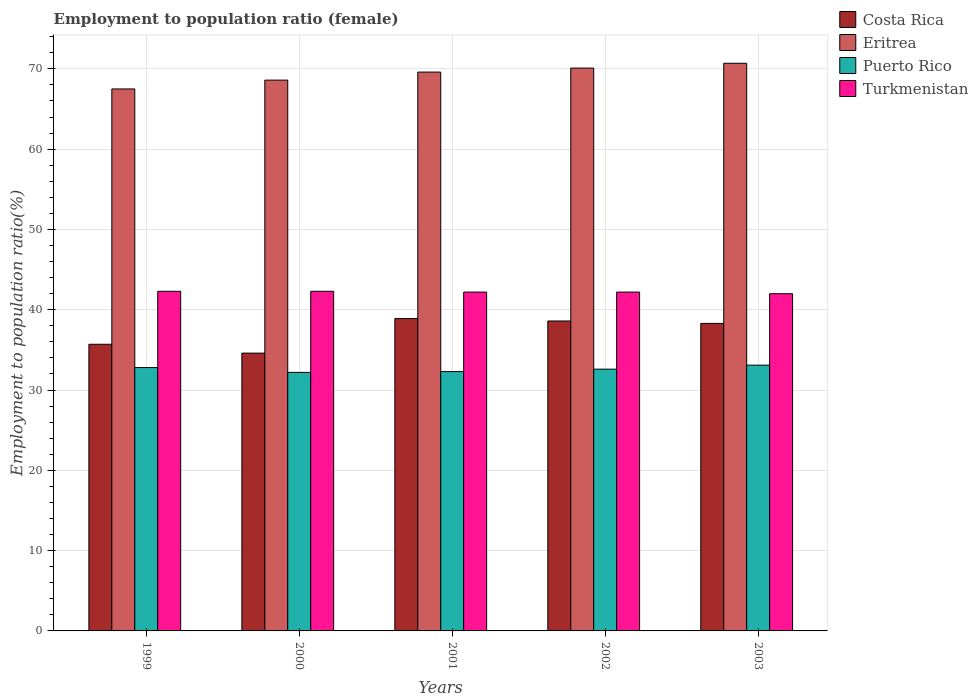How many groups of bars are there?
Make the answer very short. 5. Are the number of bars per tick equal to the number of legend labels?
Your response must be concise. Yes. Are the number of bars on each tick of the X-axis equal?
Offer a terse response. Yes. What is the employment to population ratio in Costa Rica in 1999?
Your answer should be very brief. 35.7. Across all years, what is the maximum employment to population ratio in Eritrea?
Your answer should be compact. 70.7. Across all years, what is the minimum employment to population ratio in Eritrea?
Provide a succinct answer. 67.5. In which year was the employment to population ratio in Turkmenistan maximum?
Offer a very short reply. 1999. In which year was the employment to population ratio in Turkmenistan minimum?
Make the answer very short. 2003. What is the total employment to population ratio in Puerto Rico in the graph?
Offer a terse response. 163. What is the difference between the employment to population ratio in Turkmenistan in 1999 and that in 2002?
Your answer should be compact. 0.1. What is the difference between the employment to population ratio in Eritrea in 2001 and the employment to population ratio in Costa Rica in 2002?
Make the answer very short. 31. What is the average employment to population ratio in Puerto Rico per year?
Keep it short and to the point. 32.6. In the year 2001, what is the difference between the employment to population ratio in Turkmenistan and employment to population ratio in Eritrea?
Ensure brevity in your answer.  -27.4. In how many years, is the employment to population ratio in Puerto Rico greater than 18 %?
Make the answer very short. 5. What is the ratio of the employment to population ratio in Turkmenistan in 1999 to that in 2003?
Make the answer very short. 1.01. What is the difference between the highest and the second highest employment to population ratio in Costa Rica?
Offer a very short reply. 0.3. What is the difference between the highest and the lowest employment to population ratio in Eritrea?
Your answer should be compact. 3.2. Is the sum of the employment to population ratio in Eritrea in 2001 and 2002 greater than the maximum employment to population ratio in Puerto Rico across all years?
Offer a terse response. Yes. What does the 4th bar from the left in 2000 represents?
Keep it short and to the point. Turkmenistan. Is it the case that in every year, the sum of the employment to population ratio in Costa Rica and employment to population ratio in Turkmenistan is greater than the employment to population ratio in Puerto Rico?
Keep it short and to the point. Yes. How many years are there in the graph?
Your answer should be compact. 5. Does the graph contain any zero values?
Ensure brevity in your answer.  No. Does the graph contain grids?
Provide a succinct answer. Yes. What is the title of the graph?
Offer a terse response. Employment to population ratio (female). What is the Employment to population ratio(%) of Costa Rica in 1999?
Ensure brevity in your answer.  35.7. What is the Employment to population ratio(%) of Eritrea in 1999?
Your answer should be compact. 67.5. What is the Employment to population ratio(%) of Puerto Rico in 1999?
Provide a succinct answer. 32.8. What is the Employment to population ratio(%) in Turkmenistan in 1999?
Your answer should be very brief. 42.3. What is the Employment to population ratio(%) of Costa Rica in 2000?
Offer a terse response. 34.6. What is the Employment to population ratio(%) of Eritrea in 2000?
Give a very brief answer. 68.6. What is the Employment to population ratio(%) of Puerto Rico in 2000?
Keep it short and to the point. 32.2. What is the Employment to population ratio(%) in Turkmenistan in 2000?
Offer a very short reply. 42.3. What is the Employment to population ratio(%) of Costa Rica in 2001?
Your response must be concise. 38.9. What is the Employment to population ratio(%) of Eritrea in 2001?
Provide a succinct answer. 69.6. What is the Employment to population ratio(%) of Puerto Rico in 2001?
Provide a succinct answer. 32.3. What is the Employment to population ratio(%) in Turkmenistan in 2001?
Make the answer very short. 42.2. What is the Employment to population ratio(%) of Costa Rica in 2002?
Make the answer very short. 38.6. What is the Employment to population ratio(%) of Eritrea in 2002?
Your response must be concise. 70.1. What is the Employment to population ratio(%) in Puerto Rico in 2002?
Your answer should be compact. 32.6. What is the Employment to population ratio(%) of Turkmenistan in 2002?
Keep it short and to the point. 42.2. What is the Employment to population ratio(%) of Costa Rica in 2003?
Your answer should be very brief. 38.3. What is the Employment to population ratio(%) of Eritrea in 2003?
Your response must be concise. 70.7. What is the Employment to population ratio(%) of Puerto Rico in 2003?
Offer a terse response. 33.1. Across all years, what is the maximum Employment to population ratio(%) of Costa Rica?
Keep it short and to the point. 38.9. Across all years, what is the maximum Employment to population ratio(%) of Eritrea?
Your answer should be compact. 70.7. Across all years, what is the maximum Employment to population ratio(%) in Puerto Rico?
Give a very brief answer. 33.1. Across all years, what is the maximum Employment to population ratio(%) in Turkmenistan?
Your response must be concise. 42.3. Across all years, what is the minimum Employment to population ratio(%) of Costa Rica?
Keep it short and to the point. 34.6. Across all years, what is the minimum Employment to population ratio(%) in Eritrea?
Offer a very short reply. 67.5. Across all years, what is the minimum Employment to population ratio(%) of Puerto Rico?
Provide a short and direct response. 32.2. What is the total Employment to population ratio(%) of Costa Rica in the graph?
Give a very brief answer. 186.1. What is the total Employment to population ratio(%) in Eritrea in the graph?
Offer a terse response. 346.5. What is the total Employment to population ratio(%) of Puerto Rico in the graph?
Your response must be concise. 163. What is the total Employment to population ratio(%) in Turkmenistan in the graph?
Your answer should be very brief. 211. What is the difference between the Employment to population ratio(%) of Costa Rica in 1999 and that in 2000?
Offer a terse response. 1.1. What is the difference between the Employment to population ratio(%) of Puerto Rico in 1999 and that in 2000?
Your answer should be very brief. 0.6. What is the difference between the Employment to population ratio(%) of Eritrea in 1999 and that in 2001?
Your response must be concise. -2.1. What is the difference between the Employment to population ratio(%) of Costa Rica in 1999 and that in 2002?
Ensure brevity in your answer.  -2.9. What is the difference between the Employment to population ratio(%) in Eritrea in 1999 and that in 2002?
Ensure brevity in your answer.  -2.6. What is the difference between the Employment to population ratio(%) in Costa Rica in 1999 and that in 2003?
Your answer should be compact. -2.6. What is the difference between the Employment to population ratio(%) in Eritrea in 1999 and that in 2003?
Provide a succinct answer. -3.2. What is the difference between the Employment to population ratio(%) of Puerto Rico in 1999 and that in 2003?
Offer a very short reply. -0.3. What is the difference between the Employment to population ratio(%) in Costa Rica in 2000 and that in 2001?
Your answer should be compact. -4.3. What is the difference between the Employment to population ratio(%) in Puerto Rico in 2000 and that in 2001?
Provide a short and direct response. -0.1. What is the difference between the Employment to population ratio(%) in Turkmenistan in 2000 and that in 2001?
Your answer should be very brief. 0.1. What is the difference between the Employment to population ratio(%) of Costa Rica in 2000 and that in 2002?
Make the answer very short. -4. What is the difference between the Employment to population ratio(%) in Eritrea in 2000 and that in 2002?
Provide a succinct answer. -1.5. What is the difference between the Employment to population ratio(%) of Turkmenistan in 2000 and that in 2002?
Make the answer very short. 0.1. What is the difference between the Employment to population ratio(%) in Eritrea in 2000 and that in 2003?
Your response must be concise. -2.1. What is the difference between the Employment to population ratio(%) of Puerto Rico in 2000 and that in 2003?
Your response must be concise. -0.9. What is the difference between the Employment to population ratio(%) of Turkmenistan in 2000 and that in 2003?
Your answer should be compact. 0.3. What is the difference between the Employment to population ratio(%) in Costa Rica in 2001 and that in 2002?
Your response must be concise. 0.3. What is the difference between the Employment to population ratio(%) in Turkmenistan in 2001 and that in 2002?
Offer a terse response. 0. What is the difference between the Employment to population ratio(%) in Costa Rica in 2001 and that in 2003?
Keep it short and to the point. 0.6. What is the difference between the Employment to population ratio(%) in Eritrea in 2001 and that in 2003?
Provide a short and direct response. -1.1. What is the difference between the Employment to population ratio(%) in Turkmenistan in 2001 and that in 2003?
Provide a succinct answer. 0.2. What is the difference between the Employment to population ratio(%) in Costa Rica in 2002 and that in 2003?
Give a very brief answer. 0.3. What is the difference between the Employment to population ratio(%) in Turkmenistan in 2002 and that in 2003?
Provide a short and direct response. 0.2. What is the difference between the Employment to population ratio(%) in Costa Rica in 1999 and the Employment to population ratio(%) in Eritrea in 2000?
Offer a terse response. -32.9. What is the difference between the Employment to population ratio(%) of Costa Rica in 1999 and the Employment to population ratio(%) of Puerto Rico in 2000?
Your response must be concise. 3.5. What is the difference between the Employment to population ratio(%) in Eritrea in 1999 and the Employment to population ratio(%) in Puerto Rico in 2000?
Offer a terse response. 35.3. What is the difference between the Employment to population ratio(%) in Eritrea in 1999 and the Employment to population ratio(%) in Turkmenistan in 2000?
Keep it short and to the point. 25.2. What is the difference between the Employment to population ratio(%) of Puerto Rico in 1999 and the Employment to population ratio(%) of Turkmenistan in 2000?
Your answer should be very brief. -9.5. What is the difference between the Employment to population ratio(%) of Costa Rica in 1999 and the Employment to population ratio(%) of Eritrea in 2001?
Provide a short and direct response. -33.9. What is the difference between the Employment to population ratio(%) of Costa Rica in 1999 and the Employment to population ratio(%) of Puerto Rico in 2001?
Keep it short and to the point. 3.4. What is the difference between the Employment to population ratio(%) in Eritrea in 1999 and the Employment to population ratio(%) in Puerto Rico in 2001?
Offer a very short reply. 35.2. What is the difference between the Employment to population ratio(%) of Eritrea in 1999 and the Employment to population ratio(%) of Turkmenistan in 2001?
Your answer should be compact. 25.3. What is the difference between the Employment to population ratio(%) in Costa Rica in 1999 and the Employment to population ratio(%) in Eritrea in 2002?
Keep it short and to the point. -34.4. What is the difference between the Employment to population ratio(%) of Costa Rica in 1999 and the Employment to population ratio(%) of Puerto Rico in 2002?
Provide a short and direct response. 3.1. What is the difference between the Employment to population ratio(%) of Eritrea in 1999 and the Employment to population ratio(%) of Puerto Rico in 2002?
Offer a terse response. 34.9. What is the difference between the Employment to population ratio(%) in Eritrea in 1999 and the Employment to population ratio(%) in Turkmenistan in 2002?
Offer a terse response. 25.3. What is the difference between the Employment to population ratio(%) in Puerto Rico in 1999 and the Employment to population ratio(%) in Turkmenistan in 2002?
Give a very brief answer. -9.4. What is the difference between the Employment to population ratio(%) of Costa Rica in 1999 and the Employment to population ratio(%) of Eritrea in 2003?
Ensure brevity in your answer.  -35. What is the difference between the Employment to population ratio(%) in Eritrea in 1999 and the Employment to population ratio(%) in Puerto Rico in 2003?
Your answer should be compact. 34.4. What is the difference between the Employment to population ratio(%) of Puerto Rico in 1999 and the Employment to population ratio(%) of Turkmenistan in 2003?
Ensure brevity in your answer.  -9.2. What is the difference between the Employment to population ratio(%) in Costa Rica in 2000 and the Employment to population ratio(%) in Eritrea in 2001?
Your response must be concise. -35. What is the difference between the Employment to population ratio(%) of Costa Rica in 2000 and the Employment to population ratio(%) of Turkmenistan in 2001?
Give a very brief answer. -7.6. What is the difference between the Employment to population ratio(%) of Eritrea in 2000 and the Employment to population ratio(%) of Puerto Rico in 2001?
Offer a terse response. 36.3. What is the difference between the Employment to population ratio(%) of Eritrea in 2000 and the Employment to population ratio(%) of Turkmenistan in 2001?
Your response must be concise. 26.4. What is the difference between the Employment to population ratio(%) of Puerto Rico in 2000 and the Employment to population ratio(%) of Turkmenistan in 2001?
Your answer should be compact. -10. What is the difference between the Employment to population ratio(%) of Costa Rica in 2000 and the Employment to population ratio(%) of Eritrea in 2002?
Ensure brevity in your answer.  -35.5. What is the difference between the Employment to population ratio(%) in Costa Rica in 2000 and the Employment to population ratio(%) in Puerto Rico in 2002?
Ensure brevity in your answer.  2. What is the difference between the Employment to population ratio(%) of Eritrea in 2000 and the Employment to population ratio(%) of Turkmenistan in 2002?
Your response must be concise. 26.4. What is the difference between the Employment to population ratio(%) in Costa Rica in 2000 and the Employment to population ratio(%) in Eritrea in 2003?
Your answer should be compact. -36.1. What is the difference between the Employment to population ratio(%) of Costa Rica in 2000 and the Employment to population ratio(%) of Puerto Rico in 2003?
Your answer should be compact. 1.5. What is the difference between the Employment to population ratio(%) of Eritrea in 2000 and the Employment to population ratio(%) of Puerto Rico in 2003?
Give a very brief answer. 35.5. What is the difference between the Employment to population ratio(%) of Eritrea in 2000 and the Employment to population ratio(%) of Turkmenistan in 2003?
Your answer should be compact. 26.6. What is the difference between the Employment to population ratio(%) of Puerto Rico in 2000 and the Employment to population ratio(%) of Turkmenistan in 2003?
Provide a short and direct response. -9.8. What is the difference between the Employment to population ratio(%) in Costa Rica in 2001 and the Employment to population ratio(%) in Eritrea in 2002?
Offer a terse response. -31.2. What is the difference between the Employment to population ratio(%) of Eritrea in 2001 and the Employment to population ratio(%) of Turkmenistan in 2002?
Offer a terse response. 27.4. What is the difference between the Employment to population ratio(%) in Puerto Rico in 2001 and the Employment to population ratio(%) in Turkmenistan in 2002?
Offer a terse response. -9.9. What is the difference between the Employment to population ratio(%) in Costa Rica in 2001 and the Employment to population ratio(%) in Eritrea in 2003?
Provide a succinct answer. -31.8. What is the difference between the Employment to population ratio(%) of Eritrea in 2001 and the Employment to population ratio(%) of Puerto Rico in 2003?
Give a very brief answer. 36.5. What is the difference between the Employment to population ratio(%) in Eritrea in 2001 and the Employment to population ratio(%) in Turkmenistan in 2003?
Provide a short and direct response. 27.6. What is the difference between the Employment to population ratio(%) of Puerto Rico in 2001 and the Employment to population ratio(%) of Turkmenistan in 2003?
Your answer should be compact. -9.7. What is the difference between the Employment to population ratio(%) in Costa Rica in 2002 and the Employment to population ratio(%) in Eritrea in 2003?
Your answer should be compact. -32.1. What is the difference between the Employment to population ratio(%) in Costa Rica in 2002 and the Employment to population ratio(%) in Turkmenistan in 2003?
Offer a terse response. -3.4. What is the difference between the Employment to population ratio(%) of Eritrea in 2002 and the Employment to population ratio(%) of Puerto Rico in 2003?
Your response must be concise. 37. What is the difference between the Employment to population ratio(%) in Eritrea in 2002 and the Employment to population ratio(%) in Turkmenistan in 2003?
Offer a terse response. 28.1. What is the difference between the Employment to population ratio(%) in Puerto Rico in 2002 and the Employment to population ratio(%) in Turkmenistan in 2003?
Make the answer very short. -9.4. What is the average Employment to population ratio(%) in Costa Rica per year?
Provide a short and direct response. 37.22. What is the average Employment to population ratio(%) in Eritrea per year?
Give a very brief answer. 69.3. What is the average Employment to population ratio(%) in Puerto Rico per year?
Offer a terse response. 32.6. What is the average Employment to population ratio(%) in Turkmenistan per year?
Offer a very short reply. 42.2. In the year 1999, what is the difference between the Employment to population ratio(%) in Costa Rica and Employment to population ratio(%) in Eritrea?
Make the answer very short. -31.8. In the year 1999, what is the difference between the Employment to population ratio(%) of Costa Rica and Employment to population ratio(%) of Puerto Rico?
Offer a terse response. 2.9. In the year 1999, what is the difference between the Employment to population ratio(%) of Eritrea and Employment to population ratio(%) of Puerto Rico?
Make the answer very short. 34.7. In the year 1999, what is the difference between the Employment to population ratio(%) in Eritrea and Employment to population ratio(%) in Turkmenistan?
Ensure brevity in your answer.  25.2. In the year 1999, what is the difference between the Employment to population ratio(%) of Puerto Rico and Employment to population ratio(%) of Turkmenistan?
Offer a very short reply. -9.5. In the year 2000, what is the difference between the Employment to population ratio(%) of Costa Rica and Employment to population ratio(%) of Eritrea?
Your answer should be compact. -34. In the year 2000, what is the difference between the Employment to population ratio(%) of Costa Rica and Employment to population ratio(%) of Puerto Rico?
Keep it short and to the point. 2.4. In the year 2000, what is the difference between the Employment to population ratio(%) of Eritrea and Employment to population ratio(%) of Puerto Rico?
Offer a very short reply. 36.4. In the year 2000, what is the difference between the Employment to population ratio(%) of Eritrea and Employment to population ratio(%) of Turkmenistan?
Give a very brief answer. 26.3. In the year 2000, what is the difference between the Employment to population ratio(%) in Puerto Rico and Employment to population ratio(%) in Turkmenistan?
Your answer should be very brief. -10.1. In the year 2001, what is the difference between the Employment to population ratio(%) of Costa Rica and Employment to population ratio(%) of Eritrea?
Keep it short and to the point. -30.7. In the year 2001, what is the difference between the Employment to population ratio(%) of Costa Rica and Employment to population ratio(%) of Turkmenistan?
Offer a very short reply. -3.3. In the year 2001, what is the difference between the Employment to population ratio(%) of Eritrea and Employment to population ratio(%) of Puerto Rico?
Make the answer very short. 37.3. In the year 2001, what is the difference between the Employment to population ratio(%) in Eritrea and Employment to population ratio(%) in Turkmenistan?
Your answer should be compact. 27.4. In the year 2002, what is the difference between the Employment to population ratio(%) of Costa Rica and Employment to population ratio(%) of Eritrea?
Offer a very short reply. -31.5. In the year 2002, what is the difference between the Employment to population ratio(%) in Costa Rica and Employment to population ratio(%) in Puerto Rico?
Give a very brief answer. 6. In the year 2002, what is the difference between the Employment to population ratio(%) in Eritrea and Employment to population ratio(%) in Puerto Rico?
Ensure brevity in your answer.  37.5. In the year 2002, what is the difference between the Employment to population ratio(%) in Eritrea and Employment to population ratio(%) in Turkmenistan?
Offer a terse response. 27.9. In the year 2002, what is the difference between the Employment to population ratio(%) in Puerto Rico and Employment to population ratio(%) in Turkmenistan?
Offer a very short reply. -9.6. In the year 2003, what is the difference between the Employment to population ratio(%) of Costa Rica and Employment to population ratio(%) of Eritrea?
Ensure brevity in your answer.  -32.4. In the year 2003, what is the difference between the Employment to population ratio(%) of Costa Rica and Employment to population ratio(%) of Turkmenistan?
Ensure brevity in your answer.  -3.7. In the year 2003, what is the difference between the Employment to population ratio(%) of Eritrea and Employment to population ratio(%) of Puerto Rico?
Offer a terse response. 37.6. In the year 2003, what is the difference between the Employment to population ratio(%) of Eritrea and Employment to population ratio(%) of Turkmenistan?
Your answer should be compact. 28.7. What is the ratio of the Employment to population ratio(%) in Costa Rica in 1999 to that in 2000?
Provide a short and direct response. 1.03. What is the ratio of the Employment to population ratio(%) in Puerto Rico in 1999 to that in 2000?
Make the answer very short. 1.02. What is the ratio of the Employment to population ratio(%) in Costa Rica in 1999 to that in 2001?
Your answer should be compact. 0.92. What is the ratio of the Employment to population ratio(%) of Eritrea in 1999 to that in 2001?
Your answer should be very brief. 0.97. What is the ratio of the Employment to population ratio(%) in Puerto Rico in 1999 to that in 2001?
Your answer should be very brief. 1.02. What is the ratio of the Employment to population ratio(%) in Turkmenistan in 1999 to that in 2001?
Your answer should be very brief. 1. What is the ratio of the Employment to population ratio(%) of Costa Rica in 1999 to that in 2002?
Provide a succinct answer. 0.92. What is the ratio of the Employment to population ratio(%) in Eritrea in 1999 to that in 2002?
Your response must be concise. 0.96. What is the ratio of the Employment to population ratio(%) in Costa Rica in 1999 to that in 2003?
Your response must be concise. 0.93. What is the ratio of the Employment to population ratio(%) of Eritrea in 1999 to that in 2003?
Give a very brief answer. 0.95. What is the ratio of the Employment to population ratio(%) in Puerto Rico in 1999 to that in 2003?
Provide a succinct answer. 0.99. What is the ratio of the Employment to population ratio(%) of Turkmenistan in 1999 to that in 2003?
Offer a terse response. 1.01. What is the ratio of the Employment to population ratio(%) in Costa Rica in 2000 to that in 2001?
Keep it short and to the point. 0.89. What is the ratio of the Employment to population ratio(%) of Eritrea in 2000 to that in 2001?
Provide a short and direct response. 0.99. What is the ratio of the Employment to population ratio(%) in Puerto Rico in 2000 to that in 2001?
Offer a terse response. 1. What is the ratio of the Employment to population ratio(%) in Costa Rica in 2000 to that in 2002?
Make the answer very short. 0.9. What is the ratio of the Employment to population ratio(%) in Eritrea in 2000 to that in 2002?
Your response must be concise. 0.98. What is the ratio of the Employment to population ratio(%) in Puerto Rico in 2000 to that in 2002?
Your answer should be compact. 0.99. What is the ratio of the Employment to population ratio(%) of Costa Rica in 2000 to that in 2003?
Your answer should be compact. 0.9. What is the ratio of the Employment to population ratio(%) in Eritrea in 2000 to that in 2003?
Provide a succinct answer. 0.97. What is the ratio of the Employment to population ratio(%) of Puerto Rico in 2000 to that in 2003?
Your answer should be compact. 0.97. What is the ratio of the Employment to population ratio(%) of Turkmenistan in 2000 to that in 2003?
Make the answer very short. 1.01. What is the ratio of the Employment to population ratio(%) of Costa Rica in 2001 to that in 2002?
Your answer should be compact. 1.01. What is the ratio of the Employment to population ratio(%) of Eritrea in 2001 to that in 2002?
Provide a short and direct response. 0.99. What is the ratio of the Employment to population ratio(%) in Turkmenistan in 2001 to that in 2002?
Ensure brevity in your answer.  1. What is the ratio of the Employment to population ratio(%) in Costa Rica in 2001 to that in 2003?
Provide a short and direct response. 1.02. What is the ratio of the Employment to population ratio(%) in Eritrea in 2001 to that in 2003?
Your response must be concise. 0.98. What is the ratio of the Employment to population ratio(%) in Puerto Rico in 2001 to that in 2003?
Provide a short and direct response. 0.98. What is the ratio of the Employment to population ratio(%) of Turkmenistan in 2001 to that in 2003?
Offer a very short reply. 1. What is the ratio of the Employment to population ratio(%) in Costa Rica in 2002 to that in 2003?
Your answer should be very brief. 1.01. What is the ratio of the Employment to population ratio(%) of Puerto Rico in 2002 to that in 2003?
Provide a succinct answer. 0.98. What is the ratio of the Employment to population ratio(%) in Turkmenistan in 2002 to that in 2003?
Offer a very short reply. 1. What is the difference between the highest and the second highest Employment to population ratio(%) of Costa Rica?
Give a very brief answer. 0.3. What is the difference between the highest and the lowest Employment to population ratio(%) in Costa Rica?
Make the answer very short. 4.3. What is the difference between the highest and the lowest Employment to population ratio(%) in Eritrea?
Your answer should be very brief. 3.2. What is the difference between the highest and the lowest Employment to population ratio(%) in Puerto Rico?
Provide a succinct answer. 0.9. 